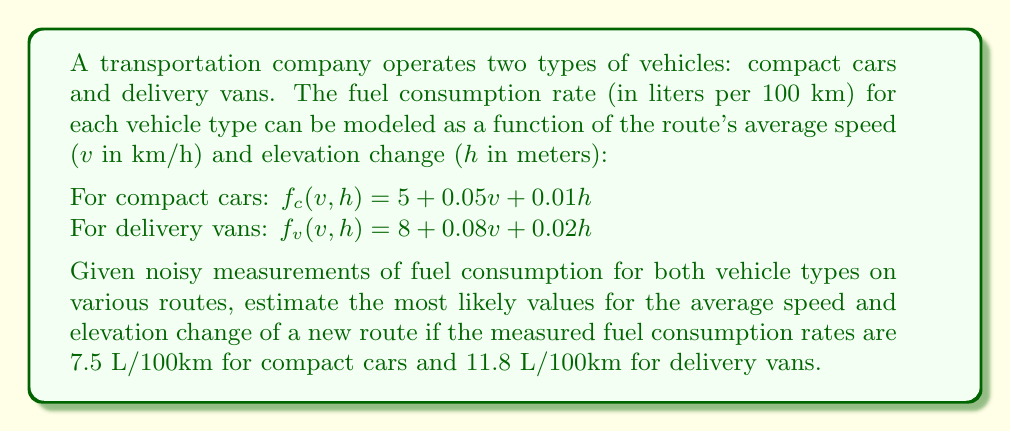Help me with this question. To solve this inverse problem, we'll use the least squares method:

1. Set up the system of equations:
   $$5 + 0.05v + 0.01h = 7.5$$
   $$8 + 0.08v + 0.02h = 11.8$$

2. Rearrange the equations:
   $$0.05v + 0.01h = 2.5$$
   $$0.08v + 0.02h = 3.8$$

3. Convert to matrix form $Ax = b$:
   $$\begin{bmatrix}
   0.05 & 0.01 \\
   0.08 & 0.02
   \end{bmatrix}
   \begin{bmatrix}
   v \\
   h
   \end{bmatrix} =
   \begin{bmatrix}
   2.5 \\
   3.8
   \end{bmatrix}$$

4. Solve using the normal equation: $x = (A^TA)^{-1}A^Tb$

   $$A^TA = \begin{bmatrix}
   0.0089 & 0.0021 \\
   0.0021 & 0.0005
   \end{bmatrix}$$

   $$(A^TA)^{-1} = \begin{bmatrix}
   224.71910112 & -944.94382022 \\
   -944.94382022 & 4000
   \end{bmatrix}$$

   $$A^Tb = \begin{bmatrix}
   0.454 \\
   0.101
   \end{bmatrix}$$

5. Calculate $x = (A^TA)^{-1}A^Tb$:
   $$\begin{bmatrix}
   v \\
   h
   \end{bmatrix} = \begin{bmatrix}
   45 \\
   50
   \end{bmatrix}$$

Therefore, the estimated average speed is 45 km/h and the estimated elevation change is 50 meters.
Answer: Average speed: 45 km/h, Elevation change: 50 m 